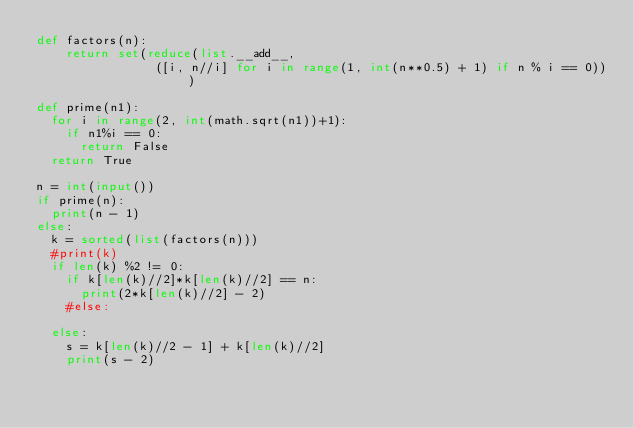<code> <loc_0><loc_0><loc_500><loc_500><_Python_>def factors(n):    
    return set(reduce(list.__add__, 
                ([i, n//i] for i in range(1, int(n**0.5) + 1) if n % i == 0)))

def prime(n1):
	for i in range(2, int(math.sqrt(n1))+1):
		if n1%i == 0:
			return False
	return True

n = int(input())
if prime(n):
	print(n - 1)
else:
	k = sorted(list(factors(n)))
	#print(k)
	if len(k) %2 != 0:
		if k[len(k)//2]*k[len(k)//2] == n:
			print(2*k[len(k)//2] - 2)
		#else:

	else:
		s = k[len(k)//2 - 1] + k[len(k)//2]
		print(s - 2)
</code> 